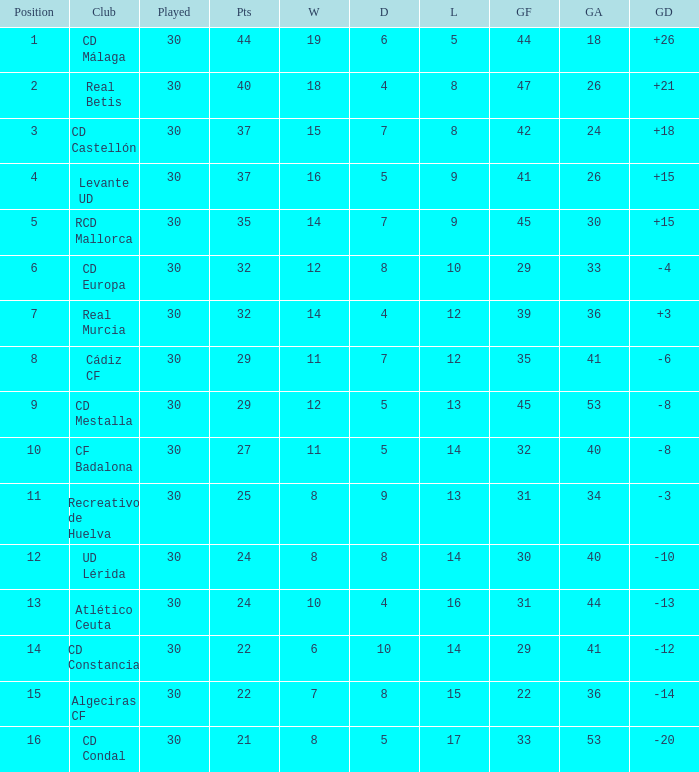What is the number of draws when played is smaller than 30? 0.0. 